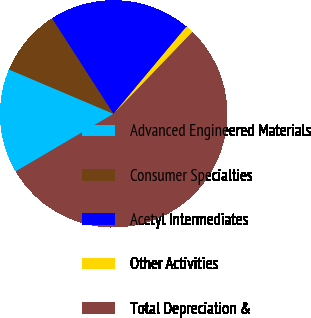<chart> <loc_0><loc_0><loc_500><loc_500><pie_chart><fcel>Advanced Engineered Materials<fcel>Consumer Specialties<fcel>Acetyl Intermediates<fcel>Other Activities<fcel>Total Depreciation &<nl><fcel>14.85%<fcel>9.52%<fcel>20.17%<fcel>1.12%<fcel>54.34%<nl></chart> 